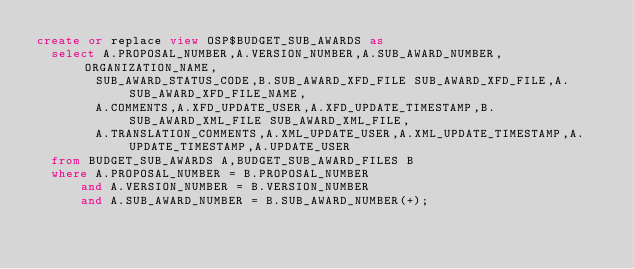Convert code to text. <code><loc_0><loc_0><loc_500><loc_500><_SQL_>create or replace view OSP$BUDGET_SUB_AWARDS as 
	select A.PROPOSAL_NUMBER,A.VERSION_NUMBER,A.SUB_AWARD_NUMBER,ORGANIZATION_NAME,
				SUB_AWARD_STATUS_CODE,B.SUB_AWARD_XFD_FILE SUB_AWARD_XFD_FILE,A.SUB_AWARD_XFD_FILE_NAME,
				A.COMMENTS,A.XFD_UPDATE_USER,A.XFD_UPDATE_TIMESTAMP,B.SUB_AWARD_XML_FILE SUB_AWARD_XML_FILE,
				A.TRANSLATION_COMMENTS,A.XML_UPDATE_USER,A.XML_UPDATE_TIMESTAMP,A.UPDATE_TIMESTAMP,A.UPDATE_USER	
	from BUDGET_SUB_AWARDS A,BUDGET_SUB_AWARD_FILES B
	where A.PROPOSAL_NUMBER = B.PROPOSAL_NUMBER 
			and A.VERSION_NUMBER = B.VERSION_NUMBER
			and A.SUB_AWARD_NUMBER = B.SUB_AWARD_NUMBER(+);</code> 